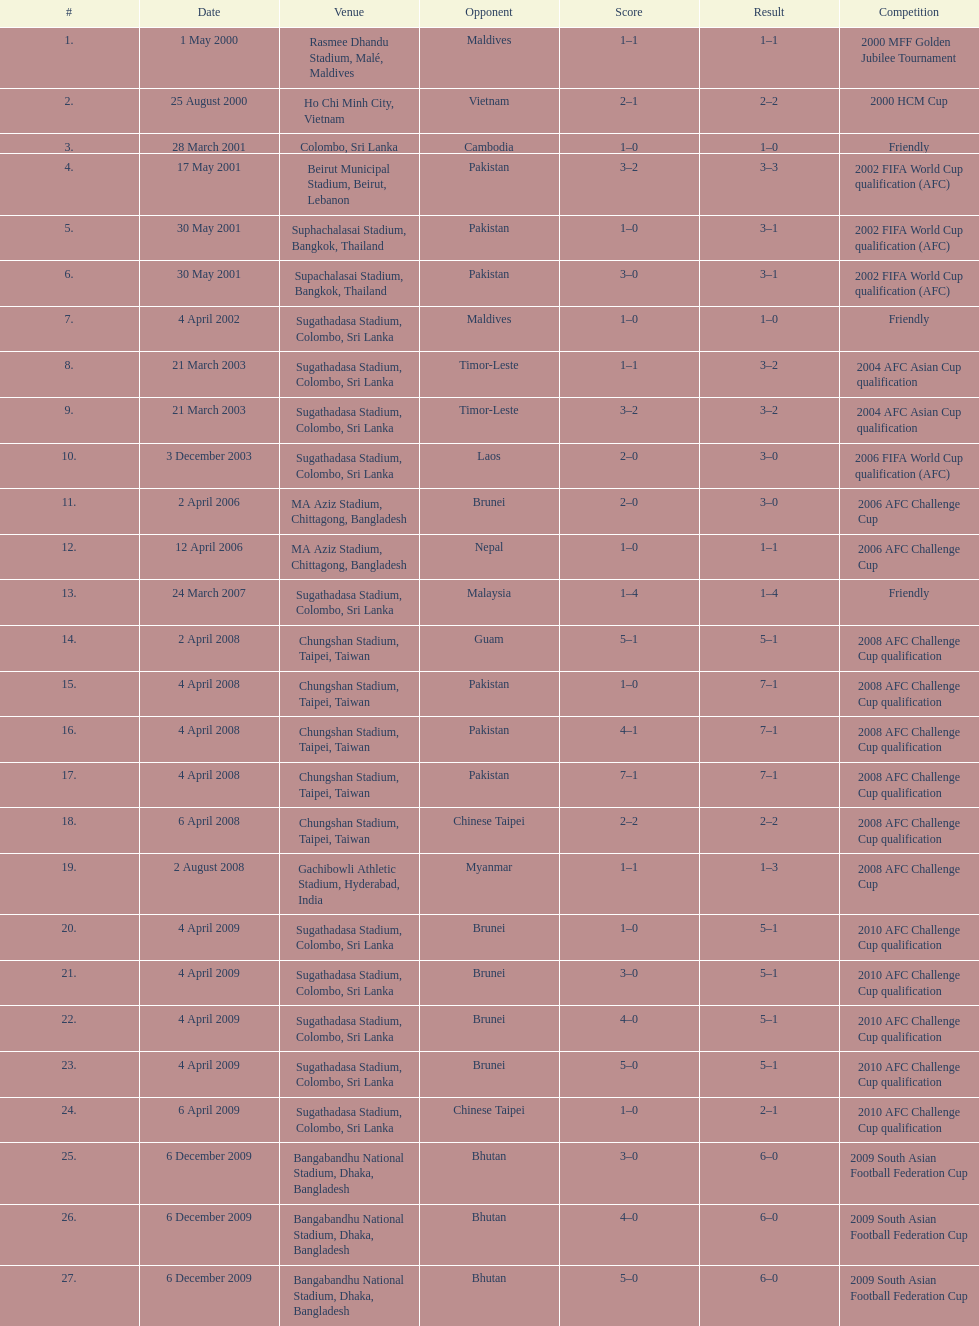In which month were there more competitions, april or december? April. 